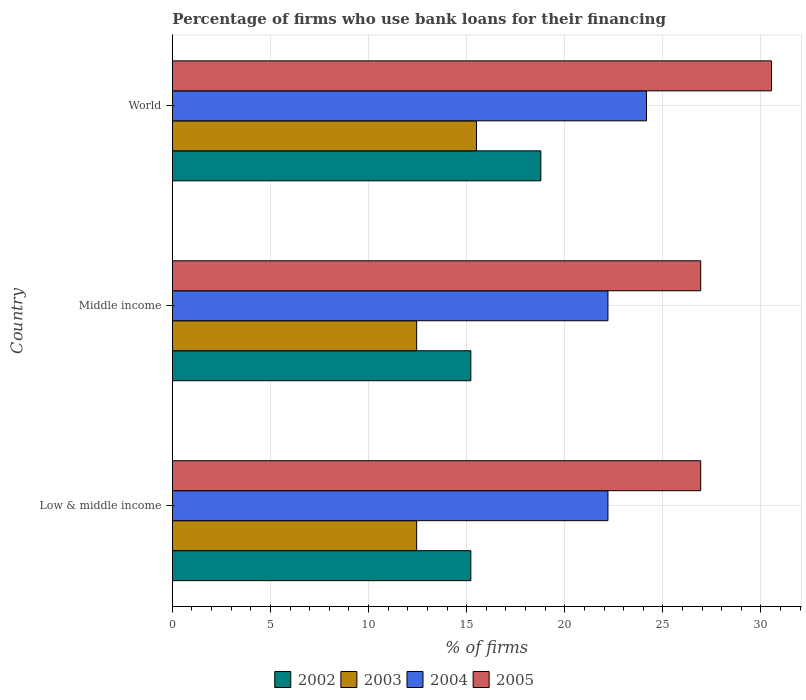How many groups of bars are there?
Your response must be concise. 3. How many bars are there on the 3rd tick from the top?
Offer a very short reply. 4. How many bars are there on the 1st tick from the bottom?
Give a very brief answer. 4. What is the percentage of firms who use bank loans for their financing in 2002 in Middle income?
Offer a very short reply. 15.21. Across all countries, what is the maximum percentage of firms who use bank loans for their financing in 2005?
Offer a terse response. 30.54. Across all countries, what is the minimum percentage of firms who use bank loans for their financing in 2002?
Offer a very short reply. 15.21. In which country was the percentage of firms who use bank loans for their financing in 2003 maximum?
Provide a short and direct response. World. What is the total percentage of firms who use bank loans for their financing in 2004 in the graph?
Provide a succinct answer. 68.57. What is the difference between the percentage of firms who use bank loans for their financing in 2004 in Middle income and that in World?
Your answer should be compact. -1.97. What is the difference between the percentage of firms who use bank loans for their financing in 2002 in World and the percentage of firms who use bank loans for their financing in 2005 in Low & middle income?
Your answer should be compact. -8.15. What is the average percentage of firms who use bank loans for their financing in 2004 per country?
Provide a succinct answer. 22.86. What is the difference between the percentage of firms who use bank loans for their financing in 2004 and percentage of firms who use bank loans for their financing in 2003 in World?
Give a very brief answer. 8.67. What is the ratio of the percentage of firms who use bank loans for their financing in 2002 in Low & middle income to that in World?
Your answer should be very brief. 0.81. Is the percentage of firms who use bank loans for their financing in 2002 in Middle income less than that in World?
Keep it short and to the point. Yes. Is the difference between the percentage of firms who use bank loans for their financing in 2004 in Low & middle income and World greater than the difference between the percentage of firms who use bank loans for their financing in 2003 in Low & middle income and World?
Provide a succinct answer. Yes. What is the difference between the highest and the second highest percentage of firms who use bank loans for their financing in 2002?
Keep it short and to the point. 3.57. What is the difference between the highest and the lowest percentage of firms who use bank loans for their financing in 2004?
Offer a terse response. 1.97. In how many countries, is the percentage of firms who use bank loans for their financing in 2005 greater than the average percentage of firms who use bank loans for their financing in 2005 taken over all countries?
Your answer should be compact. 1. Is it the case that in every country, the sum of the percentage of firms who use bank loans for their financing in 2005 and percentage of firms who use bank loans for their financing in 2004 is greater than the sum of percentage of firms who use bank loans for their financing in 2003 and percentage of firms who use bank loans for their financing in 2002?
Provide a succinct answer. Yes. What does the 4th bar from the top in World represents?
Give a very brief answer. 2002. What does the 1st bar from the bottom in Low & middle income represents?
Keep it short and to the point. 2002. Is it the case that in every country, the sum of the percentage of firms who use bank loans for their financing in 2003 and percentage of firms who use bank loans for their financing in 2002 is greater than the percentage of firms who use bank loans for their financing in 2005?
Offer a very short reply. Yes. How many bars are there?
Your answer should be compact. 12. Are all the bars in the graph horizontal?
Offer a terse response. Yes. How many countries are there in the graph?
Give a very brief answer. 3. Are the values on the major ticks of X-axis written in scientific E-notation?
Your answer should be compact. No. Does the graph contain grids?
Your response must be concise. Yes. How many legend labels are there?
Provide a succinct answer. 4. How are the legend labels stacked?
Ensure brevity in your answer.  Horizontal. What is the title of the graph?
Ensure brevity in your answer.  Percentage of firms who use bank loans for their financing. Does "1964" appear as one of the legend labels in the graph?
Give a very brief answer. No. What is the label or title of the X-axis?
Give a very brief answer. % of firms. What is the label or title of the Y-axis?
Make the answer very short. Country. What is the % of firms in 2002 in Low & middle income?
Your answer should be compact. 15.21. What is the % of firms of 2003 in Low & middle income?
Your answer should be compact. 12.45. What is the % of firms of 2004 in Low & middle income?
Provide a short and direct response. 22.2. What is the % of firms of 2005 in Low & middle income?
Make the answer very short. 26.93. What is the % of firms in 2002 in Middle income?
Offer a very short reply. 15.21. What is the % of firms of 2003 in Middle income?
Your answer should be very brief. 12.45. What is the % of firms of 2005 in Middle income?
Ensure brevity in your answer.  26.93. What is the % of firms in 2002 in World?
Your answer should be compact. 18.78. What is the % of firms of 2004 in World?
Offer a very short reply. 24.17. What is the % of firms in 2005 in World?
Keep it short and to the point. 30.54. Across all countries, what is the maximum % of firms in 2002?
Make the answer very short. 18.78. Across all countries, what is the maximum % of firms of 2004?
Give a very brief answer. 24.17. Across all countries, what is the maximum % of firms of 2005?
Ensure brevity in your answer.  30.54. Across all countries, what is the minimum % of firms of 2002?
Offer a terse response. 15.21. Across all countries, what is the minimum % of firms of 2003?
Provide a succinct answer. 12.45. Across all countries, what is the minimum % of firms in 2004?
Your answer should be compact. 22.2. Across all countries, what is the minimum % of firms in 2005?
Give a very brief answer. 26.93. What is the total % of firms in 2002 in the graph?
Make the answer very short. 49.21. What is the total % of firms of 2003 in the graph?
Make the answer very short. 40.4. What is the total % of firms of 2004 in the graph?
Ensure brevity in your answer.  68.57. What is the total % of firms in 2005 in the graph?
Give a very brief answer. 84.39. What is the difference between the % of firms in 2002 in Low & middle income and that in Middle income?
Provide a succinct answer. 0. What is the difference between the % of firms in 2003 in Low & middle income and that in Middle income?
Give a very brief answer. 0. What is the difference between the % of firms of 2002 in Low & middle income and that in World?
Your answer should be very brief. -3.57. What is the difference between the % of firms of 2003 in Low & middle income and that in World?
Your response must be concise. -3.05. What is the difference between the % of firms in 2004 in Low & middle income and that in World?
Your answer should be very brief. -1.97. What is the difference between the % of firms in 2005 in Low & middle income and that in World?
Provide a short and direct response. -3.61. What is the difference between the % of firms of 2002 in Middle income and that in World?
Your answer should be compact. -3.57. What is the difference between the % of firms in 2003 in Middle income and that in World?
Give a very brief answer. -3.05. What is the difference between the % of firms of 2004 in Middle income and that in World?
Your answer should be compact. -1.97. What is the difference between the % of firms of 2005 in Middle income and that in World?
Offer a terse response. -3.61. What is the difference between the % of firms in 2002 in Low & middle income and the % of firms in 2003 in Middle income?
Ensure brevity in your answer.  2.76. What is the difference between the % of firms in 2002 in Low & middle income and the % of firms in 2004 in Middle income?
Your answer should be very brief. -6.99. What is the difference between the % of firms of 2002 in Low & middle income and the % of firms of 2005 in Middle income?
Offer a very short reply. -11.72. What is the difference between the % of firms in 2003 in Low & middle income and the % of firms in 2004 in Middle income?
Provide a short and direct response. -9.75. What is the difference between the % of firms in 2003 in Low & middle income and the % of firms in 2005 in Middle income?
Your answer should be very brief. -14.48. What is the difference between the % of firms of 2004 in Low & middle income and the % of firms of 2005 in Middle income?
Provide a short and direct response. -4.73. What is the difference between the % of firms in 2002 in Low & middle income and the % of firms in 2003 in World?
Keep it short and to the point. -0.29. What is the difference between the % of firms in 2002 in Low & middle income and the % of firms in 2004 in World?
Offer a terse response. -8.95. What is the difference between the % of firms in 2002 in Low & middle income and the % of firms in 2005 in World?
Make the answer very short. -15.33. What is the difference between the % of firms of 2003 in Low & middle income and the % of firms of 2004 in World?
Your answer should be compact. -11.72. What is the difference between the % of firms in 2003 in Low & middle income and the % of firms in 2005 in World?
Provide a short and direct response. -18.09. What is the difference between the % of firms of 2004 in Low & middle income and the % of firms of 2005 in World?
Keep it short and to the point. -8.34. What is the difference between the % of firms in 2002 in Middle income and the % of firms in 2003 in World?
Your answer should be compact. -0.29. What is the difference between the % of firms in 2002 in Middle income and the % of firms in 2004 in World?
Offer a very short reply. -8.95. What is the difference between the % of firms of 2002 in Middle income and the % of firms of 2005 in World?
Your answer should be very brief. -15.33. What is the difference between the % of firms in 2003 in Middle income and the % of firms in 2004 in World?
Offer a very short reply. -11.72. What is the difference between the % of firms in 2003 in Middle income and the % of firms in 2005 in World?
Ensure brevity in your answer.  -18.09. What is the difference between the % of firms in 2004 in Middle income and the % of firms in 2005 in World?
Your answer should be very brief. -8.34. What is the average % of firms of 2002 per country?
Make the answer very short. 16.4. What is the average % of firms in 2003 per country?
Your answer should be very brief. 13.47. What is the average % of firms of 2004 per country?
Provide a succinct answer. 22.86. What is the average % of firms in 2005 per country?
Make the answer very short. 28.13. What is the difference between the % of firms in 2002 and % of firms in 2003 in Low & middle income?
Ensure brevity in your answer.  2.76. What is the difference between the % of firms of 2002 and % of firms of 2004 in Low & middle income?
Your answer should be very brief. -6.99. What is the difference between the % of firms of 2002 and % of firms of 2005 in Low & middle income?
Ensure brevity in your answer.  -11.72. What is the difference between the % of firms of 2003 and % of firms of 2004 in Low & middle income?
Provide a succinct answer. -9.75. What is the difference between the % of firms in 2003 and % of firms in 2005 in Low & middle income?
Provide a succinct answer. -14.48. What is the difference between the % of firms of 2004 and % of firms of 2005 in Low & middle income?
Offer a terse response. -4.73. What is the difference between the % of firms of 2002 and % of firms of 2003 in Middle income?
Provide a succinct answer. 2.76. What is the difference between the % of firms of 2002 and % of firms of 2004 in Middle income?
Give a very brief answer. -6.99. What is the difference between the % of firms of 2002 and % of firms of 2005 in Middle income?
Keep it short and to the point. -11.72. What is the difference between the % of firms in 2003 and % of firms in 2004 in Middle income?
Your response must be concise. -9.75. What is the difference between the % of firms of 2003 and % of firms of 2005 in Middle income?
Give a very brief answer. -14.48. What is the difference between the % of firms of 2004 and % of firms of 2005 in Middle income?
Provide a short and direct response. -4.73. What is the difference between the % of firms of 2002 and % of firms of 2003 in World?
Your response must be concise. 3.28. What is the difference between the % of firms in 2002 and % of firms in 2004 in World?
Your response must be concise. -5.39. What is the difference between the % of firms in 2002 and % of firms in 2005 in World?
Your answer should be compact. -11.76. What is the difference between the % of firms in 2003 and % of firms in 2004 in World?
Provide a short and direct response. -8.67. What is the difference between the % of firms of 2003 and % of firms of 2005 in World?
Keep it short and to the point. -15.04. What is the difference between the % of firms in 2004 and % of firms in 2005 in World?
Keep it short and to the point. -6.37. What is the ratio of the % of firms of 2002 in Low & middle income to that in Middle income?
Make the answer very short. 1. What is the ratio of the % of firms of 2005 in Low & middle income to that in Middle income?
Your response must be concise. 1. What is the ratio of the % of firms of 2002 in Low & middle income to that in World?
Offer a terse response. 0.81. What is the ratio of the % of firms in 2003 in Low & middle income to that in World?
Ensure brevity in your answer.  0.8. What is the ratio of the % of firms in 2004 in Low & middle income to that in World?
Provide a short and direct response. 0.92. What is the ratio of the % of firms in 2005 in Low & middle income to that in World?
Keep it short and to the point. 0.88. What is the ratio of the % of firms of 2002 in Middle income to that in World?
Provide a succinct answer. 0.81. What is the ratio of the % of firms of 2003 in Middle income to that in World?
Keep it short and to the point. 0.8. What is the ratio of the % of firms of 2004 in Middle income to that in World?
Your response must be concise. 0.92. What is the ratio of the % of firms of 2005 in Middle income to that in World?
Keep it short and to the point. 0.88. What is the difference between the highest and the second highest % of firms of 2002?
Offer a terse response. 3.57. What is the difference between the highest and the second highest % of firms in 2003?
Offer a terse response. 3.05. What is the difference between the highest and the second highest % of firms in 2004?
Give a very brief answer. 1.97. What is the difference between the highest and the second highest % of firms of 2005?
Your response must be concise. 3.61. What is the difference between the highest and the lowest % of firms of 2002?
Ensure brevity in your answer.  3.57. What is the difference between the highest and the lowest % of firms of 2003?
Provide a succinct answer. 3.05. What is the difference between the highest and the lowest % of firms in 2004?
Provide a short and direct response. 1.97. What is the difference between the highest and the lowest % of firms in 2005?
Give a very brief answer. 3.61. 